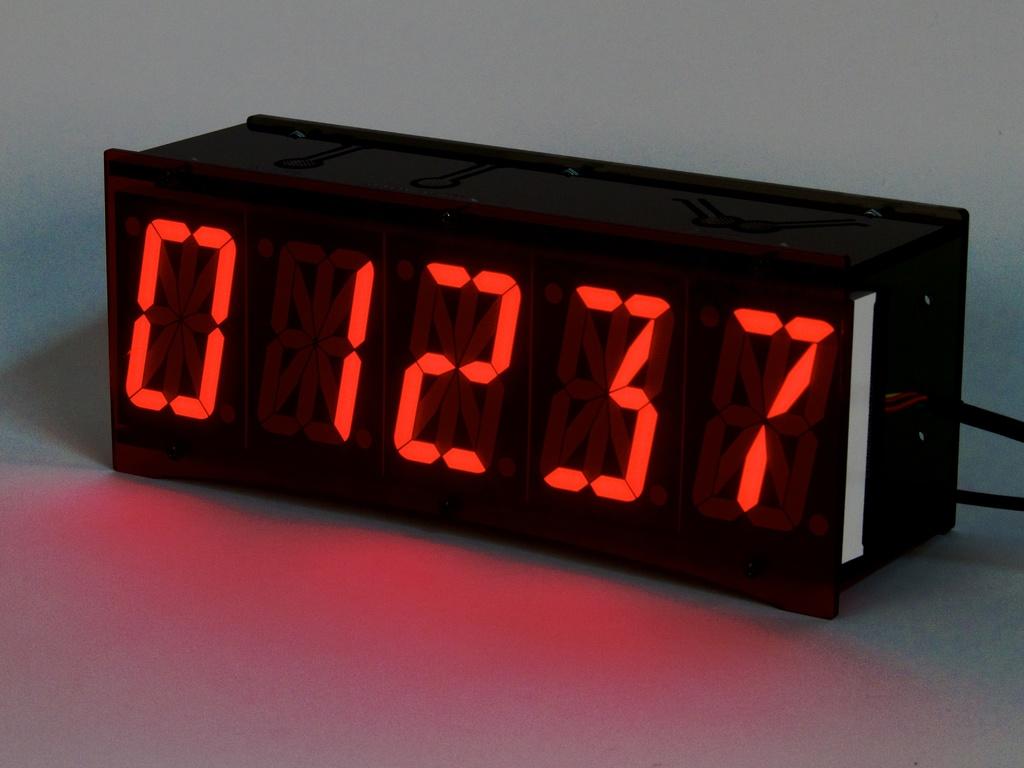What time is it?
Your response must be concise. 12:37. What are the numbers on the devic?
Give a very brief answer. 01237. 